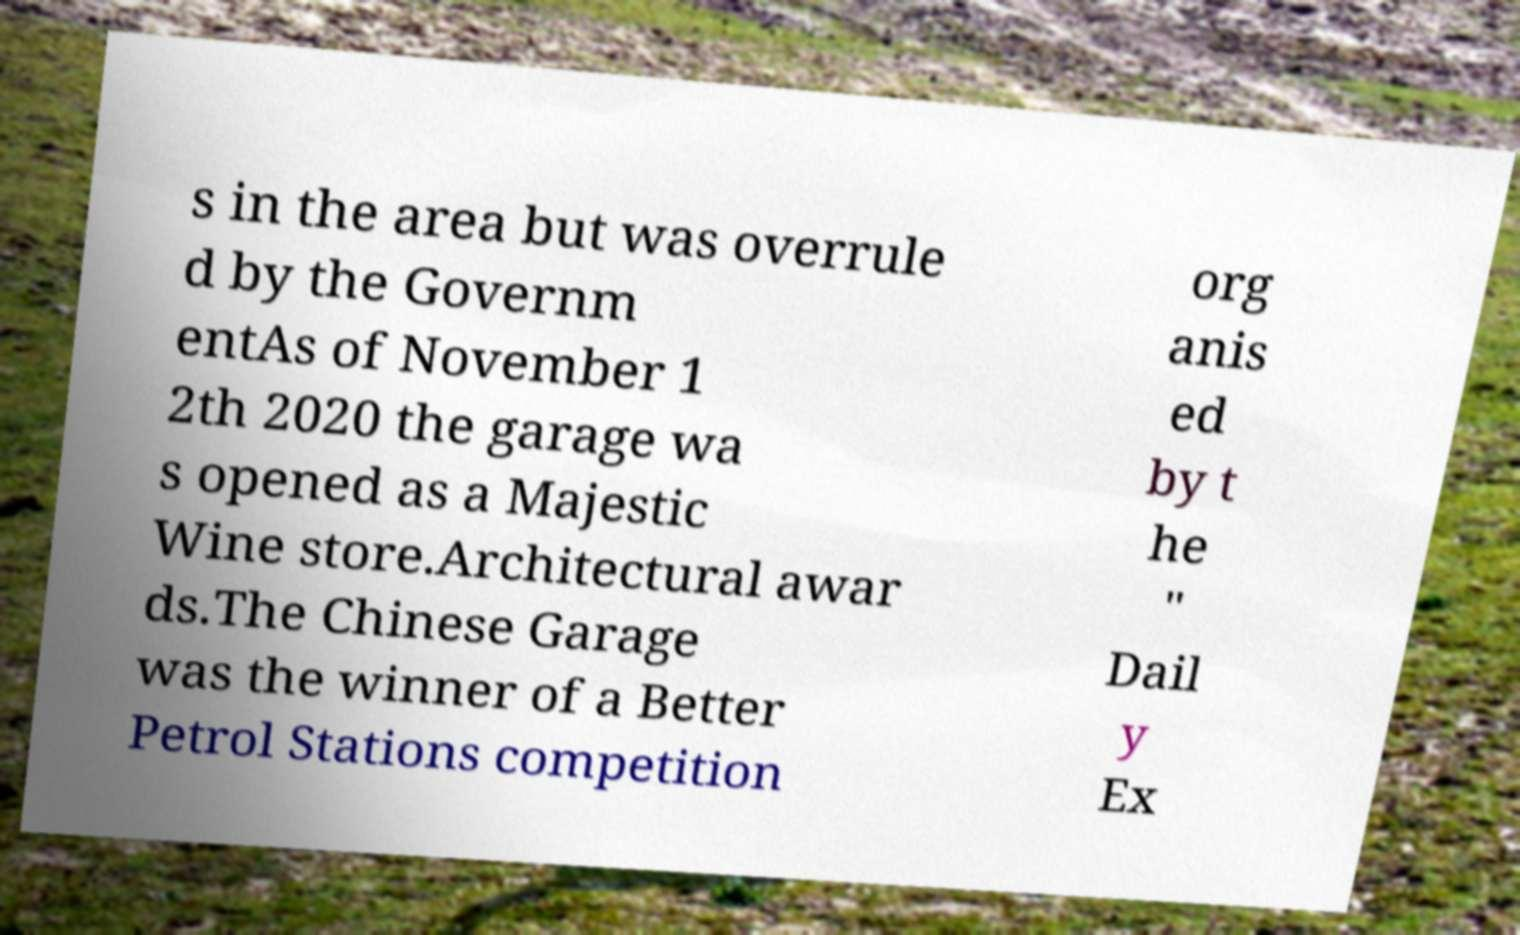Can you read and provide the text displayed in the image?This photo seems to have some interesting text. Can you extract and type it out for me? s in the area but was overrule d by the Governm entAs of November 1 2th 2020 the garage wa s opened as a Majestic Wine store.Architectural awar ds.The Chinese Garage was the winner of a Better Petrol Stations competition org anis ed by t he " Dail y Ex 